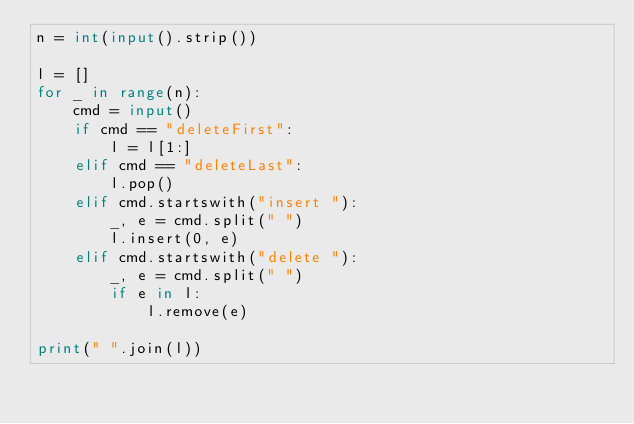<code> <loc_0><loc_0><loc_500><loc_500><_Python_>n = int(input().strip())

l = []
for _ in range(n):
    cmd = input()
    if cmd == "deleteFirst":
        l = l[1:]
    elif cmd == "deleteLast":
        l.pop()
    elif cmd.startswith("insert "):
        _, e = cmd.split(" ")
        l.insert(0, e)
    elif cmd.startswith("delete "):
        _, e = cmd.split(" ")
        if e in l:
            l.remove(e)

print(" ".join(l))</code> 